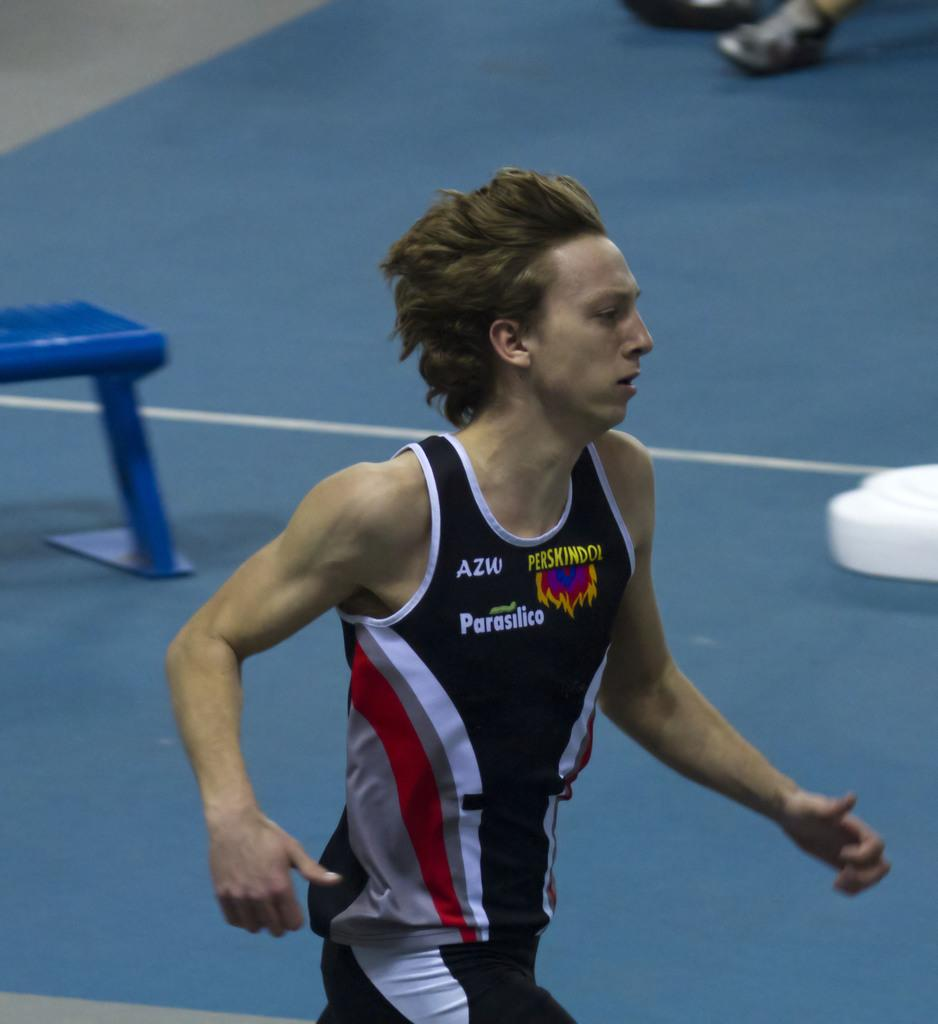Provide a one-sentence caption for the provided image. A man wears a shirt with "AZW" on the upper right side. 